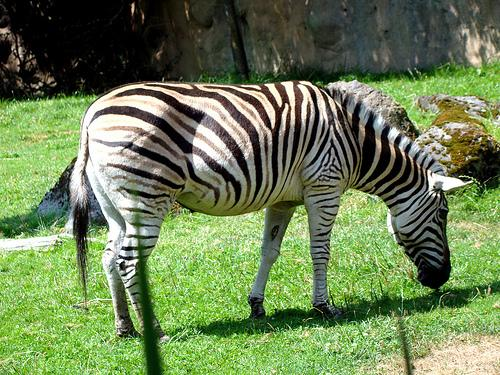Estimate the total number of zebra-related objects and observations mentioned in the image. There are approximately 26 objects and observations related to the zebra. Identify three distinct body parts of the zebra in the image and describe their features. The zebra's face and ears have distinct stripes, its tail is bushy, and its legs are striped with black and white patterns. Count and describe the types of stripes observed on the zebra. There are three types of stripes on the zebra: black and white, black white and brown, and just black and white. What complex reasoning can you derive about the zebra's behavior? The zebra might be grazing to replenish its energy, which can indicate its current environment is rich in resources and safe from predators. How many rocks can you find in the image and what are their characteristics? There are five rocks, three of which are covered in moss. The other two rocks are large and flat, lying on the ground. Describe the wall in the image and mention a detail not previously mentioned about it. It is a large stone wall with a shadow on it. Provide a brief description of the surroundings of the zebra in the image. The zebra is surrounded by a grassy field with a large stone wall, moss-covered rocks, and patches of brown grass. What sentiment can be inferred from the image based on its content? The sentiment of the image can be described as calm and peaceful since it features a zebra grazing in a grassy field. What is the primary animal featured in the image and what is it doing? The primary animal is a zebra, and it is standing in grass, eating and lowering its head to eat more grass. What type of field is present in the image and what is its condition? There is a grassy field in the image, which is mostly lush and green, but also has some patches of brown grass. 